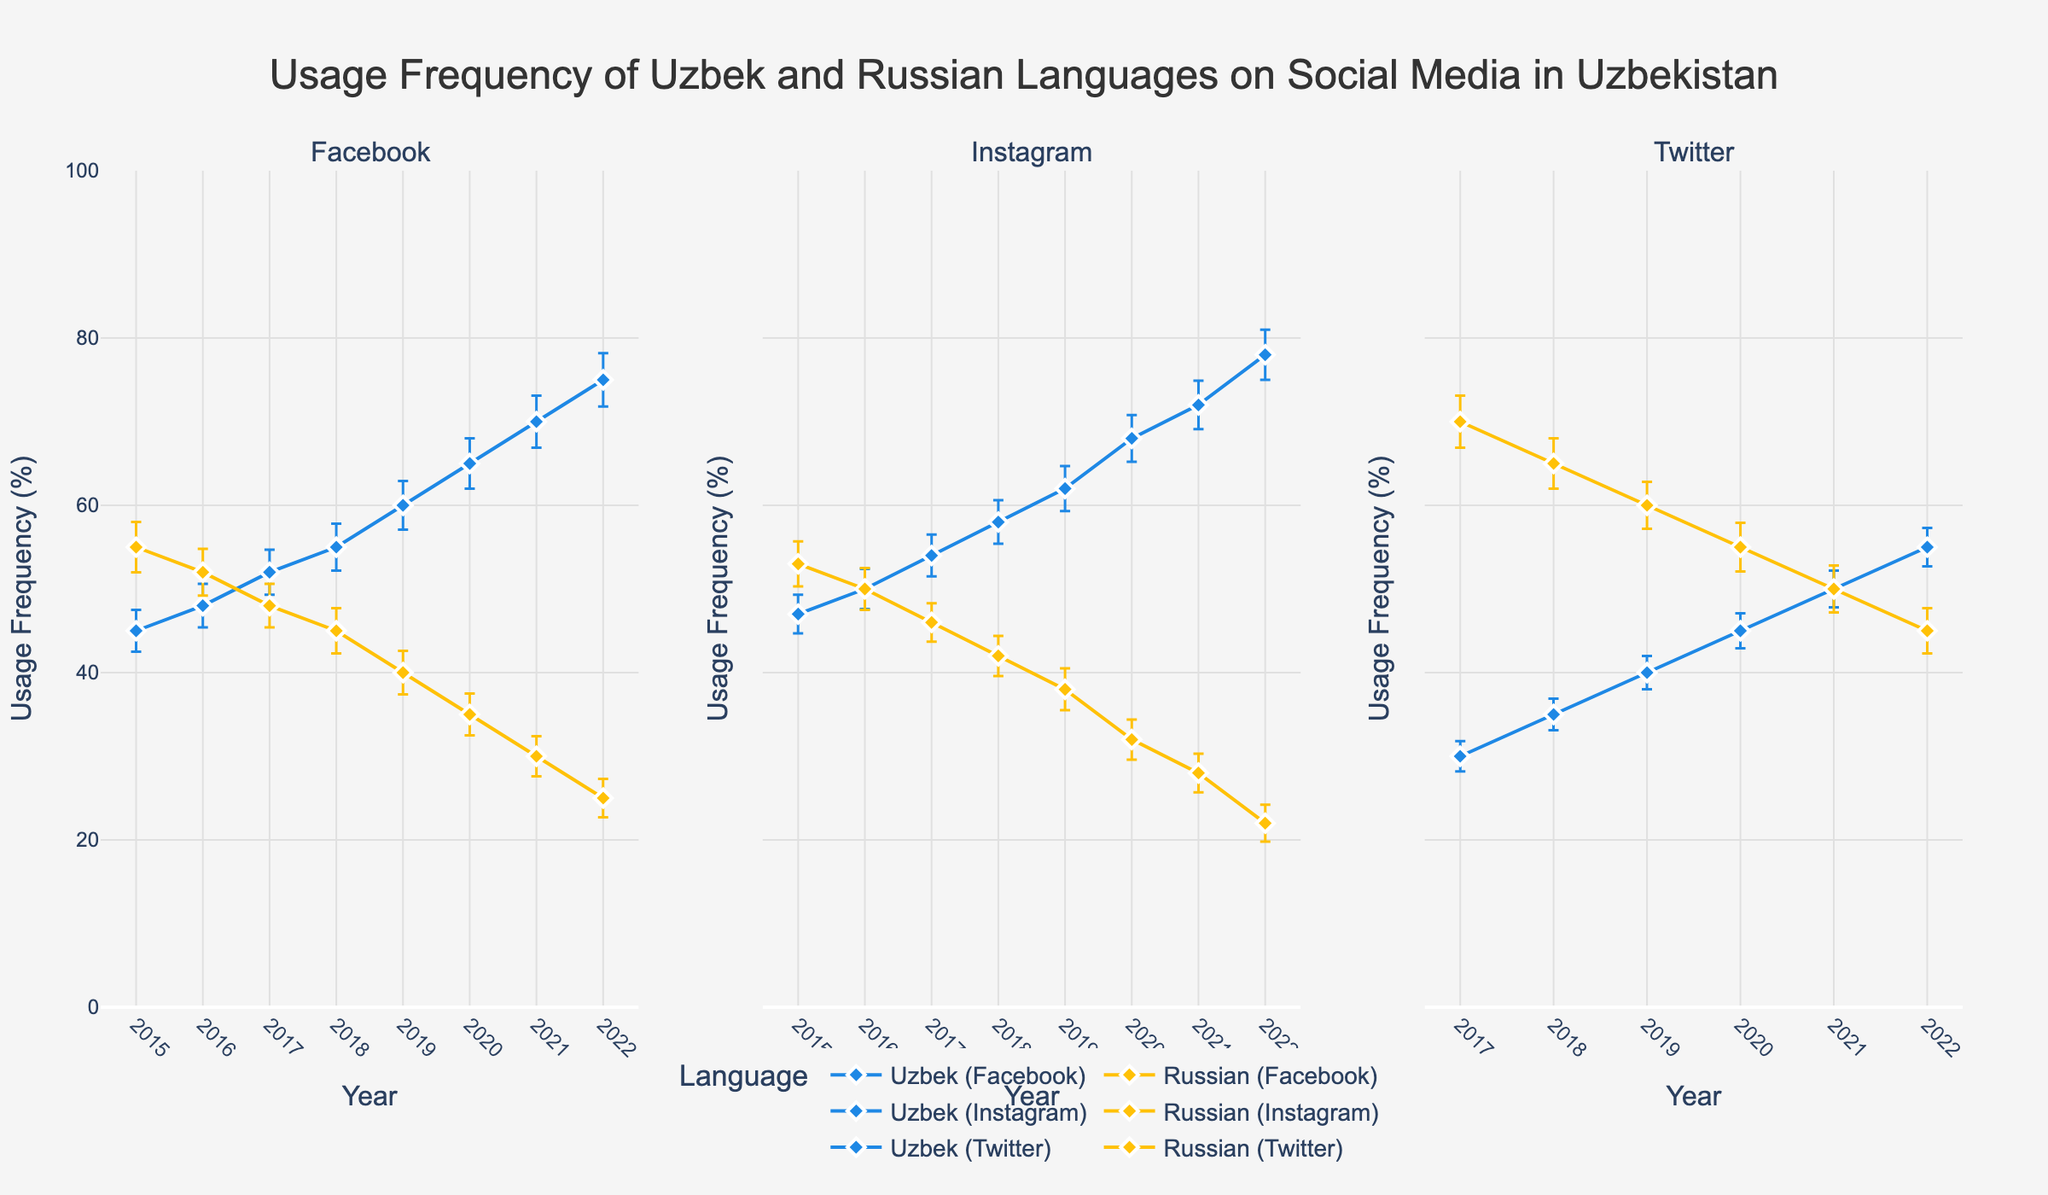What is the title of the figure? The title of the figure can be easily identified as it is prominently displayed at the top of the plot.
Answer: Usage Frequency of Uzbek and Russian Languages on Social Media in Uzbekistan In which year did the usage frequency of Uzbek language on Instagram exceed 70%? Locate the Instagram subplot and follow the Uzbek language usage line. Note the year the line exceeds the 70% mark.
Answer: 2021 How did the usage frequency of the Uzbek language on Twitter change from 2017 to 2022? Follow the Uzbek language line in the Twitter subplot and observe the values from 2017 to 2022. Note the increasing or decreasing trend.
Answer: It increased Compare the usage frequencies of Uzbek and Russian on Facebook in 2020. Which language had higher usage? In the Facebook subplot, compare the two lines (Uzbek and Russian) for the year 2020 and determine which is higher.
Answer: Uzbek What was the approximate error margin for Russian language usage on Facebook in 2019? Locate the Facebook subplot, find the data point for Russian language in 2019, and observe the error bars' length.
Answer: 2.6% Which platform showed the most significant shift in language preference between Uzbek and Russian from 2015 to 2022? Compare the trends of usage frequencies for both languages across all three platforms. Identify the platform with the greatest changes or shifts between the starting and ending points.
Answer: Facebook On which platform in 2022 did the Russian language have the lowest usage frequency, and what was that frequency? For the year 2022, look at all three subplots and compare the Russian language usage frequencies to identify the lowest.
Answer: Instagram, 22% What is the general trend for the usage of Russian language on Twitter from 2017 to 2022? Observe the Russian language line in the Twitter subplot from 2017 to 2022 and identify the overall trend, whether it is increasing, decreasing, or remaining stable.
Answer: Decreasing Calculate the average usage frequency of the Uzbek language on Instagram across the years shown. Sum the usage frequencies of the Uzbek language on Instagram for all years and divide by the number of years (2015-2022).
Answer: (47 + 50 + 54 + 58 + 62 + 68 + 72 + 78) / 8 = 61.125 Which year showed an equal usage frequency of Uzbek and Russian languages on Twitter, and what was the percentage? In the Twitter subplot, identify the year where both lines intersect or have the same value.
Answer: 2021, 50% 